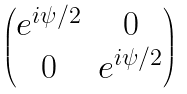<formula> <loc_0><loc_0><loc_500><loc_500>\begin{pmatrix} e ^ { i \psi / 2 } & 0 \\ 0 & e ^ { i \psi / 2 } \end{pmatrix}</formula> 